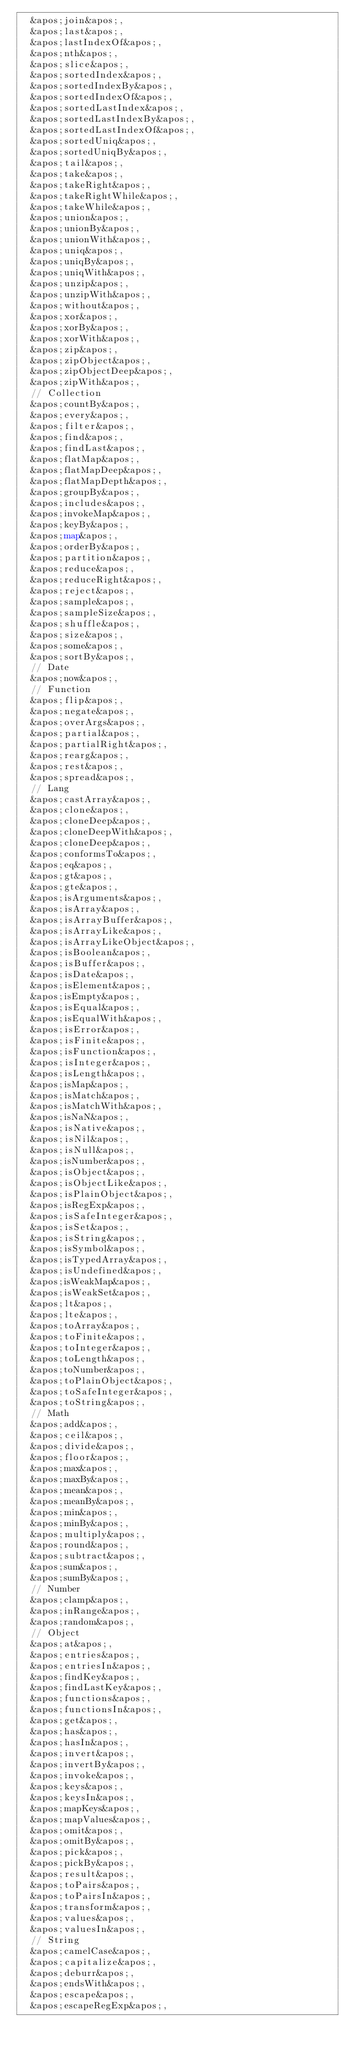<code> <loc_0><loc_0><loc_500><loc_500><_HTML_>  &apos;join&apos;,
  &apos;last&apos;,
  &apos;lastIndexOf&apos;,
  &apos;nth&apos;,
  &apos;slice&apos;,
  &apos;sortedIndex&apos;,
  &apos;sortedIndexBy&apos;,
  &apos;sortedIndexOf&apos;,
  &apos;sortedLastIndex&apos;,
  &apos;sortedLastIndexBy&apos;,
  &apos;sortedLastIndexOf&apos;,
  &apos;sortedUniq&apos;,
  &apos;sortedUniqBy&apos;,
  &apos;tail&apos;,
  &apos;take&apos;,
  &apos;takeRight&apos;,
  &apos;takeRightWhile&apos;,
  &apos;takeWhile&apos;,
  &apos;union&apos;,
  &apos;unionBy&apos;,
  &apos;unionWith&apos;,
  &apos;uniq&apos;,
  &apos;uniqBy&apos;,
  &apos;uniqWith&apos;,
  &apos;unzip&apos;,
  &apos;unzipWith&apos;,
  &apos;without&apos;,
  &apos;xor&apos;,
  &apos;xorBy&apos;,
  &apos;xorWith&apos;,
  &apos;zip&apos;,
  &apos;zipObject&apos;,
  &apos;zipObjectDeep&apos;,
  &apos;zipWith&apos;,
  // Collection
  &apos;countBy&apos;,
  &apos;every&apos;,
  &apos;filter&apos;,
  &apos;find&apos;,
  &apos;findLast&apos;,
  &apos;flatMap&apos;,
  &apos;flatMapDeep&apos;,
  &apos;flatMapDepth&apos;,
  &apos;groupBy&apos;,
  &apos;includes&apos;,
  &apos;invokeMap&apos;,
  &apos;keyBy&apos;,
  &apos;map&apos;,
  &apos;orderBy&apos;,
  &apos;partition&apos;,
  &apos;reduce&apos;,
  &apos;reduceRight&apos;,
  &apos;reject&apos;,
  &apos;sample&apos;,
  &apos;sampleSize&apos;,
  &apos;shuffle&apos;,
  &apos;size&apos;,
  &apos;some&apos;,
  &apos;sortBy&apos;,
  // Date
  &apos;now&apos;,
  // Function
  &apos;flip&apos;,
  &apos;negate&apos;,
  &apos;overArgs&apos;,
  &apos;partial&apos;,
  &apos;partialRight&apos;,
  &apos;rearg&apos;,
  &apos;rest&apos;,
  &apos;spread&apos;,
  // Lang
  &apos;castArray&apos;,
  &apos;clone&apos;,
  &apos;cloneDeep&apos;,
  &apos;cloneDeepWith&apos;,
  &apos;cloneDeep&apos;,
  &apos;conformsTo&apos;,
  &apos;eq&apos;,
  &apos;gt&apos;,
  &apos;gte&apos;,
  &apos;isArguments&apos;,
  &apos;isArray&apos;,
  &apos;isArrayBuffer&apos;,
  &apos;isArrayLike&apos;,
  &apos;isArrayLikeObject&apos;,
  &apos;isBoolean&apos;,
  &apos;isBuffer&apos;,
  &apos;isDate&apos;,
  &apos;isElement&apos;,
  &apos;isEmpty&apos;,
  &apos;isEqual&apos;,
  &apos;isEqualWith&apos;,
  &apos;isError&apos;,
  &apos;isFinite&apos;,
  &apos;isFunction&apos;,
  &apos;isInteger&apos;,
  &apos;isLength&apos;,
  &apos;isMap&apos;,
  &apos;isMatch&apos;,
  &apos;isMatchWith&apos;,
  &apos;isNaN&apos;,
  &apos;isNative&apos;,
  &apos;isNil&apos;,
  &apos;isNull&apos;,
  &apos;isNumber&apos;,
  &apos;isObject&apos;,
  &apos;isObjectLike&apos;,
  &apos;isPlainObject&apos;,
  &apos;isRegExp&apos;,
  &apos;isSafeInteger&apos;,
  &apos;isSet&apos;,
  &apos;isString&apos;,
  &apos;isSymbol&apos;,
  &apos;isTypedArray&apos;,
  &apos;isUndefined&apos;,
  &apos;isWeakMap&apos;,
  &apos;isWeakSet&apos;,
  &apos;lt&apos;,
  &apos;lte&apos;,
  &apos;toArray&apos;,
  &apos;toFinite&apos;,
  &apos;toInteger&apos;,
  &apos;toLength&apos;,
  &apos;toNumber&apos;,
  &apos;toPlainObject&apos;,
  &apos;toSafeInteger&apos;,
  &apos;toString&apos;,
  // Math
  &apos;add&apos;,
  &apos;ceil&apos;,
  &apos;divide&apos;,
  &apos;floor&apos;,
  &apos;max&apos;,
  &apos;maxBy&apos;,
  &apos;mean&apos;,
  &apos;meanBy&apos;,
  &apos;min&apos;,
  &apos;minBy&apos;,
  &apos;multiply&apos;,
  &apos;round&apos;,
  &apos;subtract&apos;,
  &apos;sum&apos;,
  &apos;sumBy&apos;,
  // Number
  &apos;clamp&apos;,
  &apos;inRange&apos;,
  &apos;random&apos;,
  // Object
  &apos;at&apos;,
  &apos;entries&apos;,
  &apos;entriesIn&apos;,
  &apos;findKey&apos;,
  &apos;findLastKey&apos;,
  &apos;functions&apos;,
  &apos;functionsIn&apos;,
  &apos;get&apos;,
  &apos;has&apos;,
  &apos;hasIn&apos;,
  &apos;invert&apos;,
  &apos;invertBy&apos;,
  &apos;invoke&apos;,
  &apos;keys&apos;,
  &apos;keysIn&apos;,
  &apos;mapKeys&apos;,
  &apos;mapValues&apos;,
  &apos;omit&apos;,
  &apos;omitBy&apos;,
  &apos;pick&apos;,
  &apos;pickBy&apos;,
  &apos;result&apos;,
  &apos;toPairs&apos;,
  &apos;toPairsIn&apos;,
  &apos;transform&apos;,
  &apos;values&apos;,
  &apos;valuesIn&apos;,
  // String
  &apos;camelCase&apos;,
  &apos;capitalize&apos;,
  &apos;deburr&apos;,
  &apos;endsWith&apos;,
  &apos;escape&apos;,
  &apos;escapeRegExp&apos;,</code> 